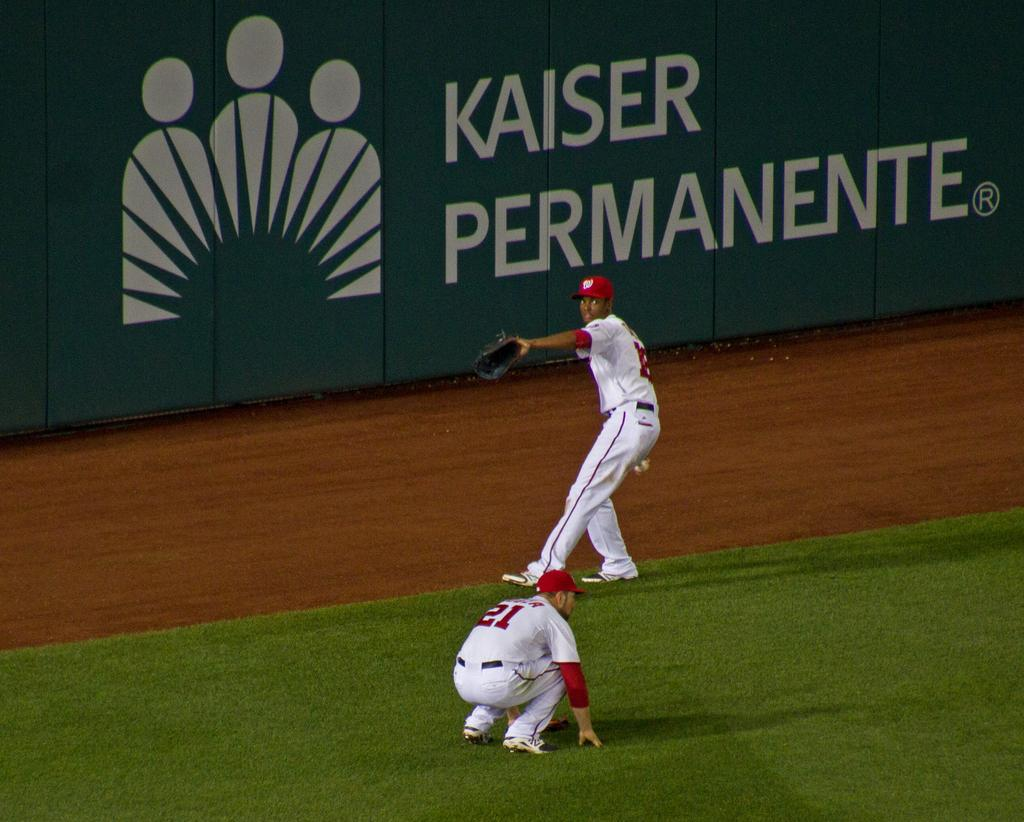<image>
Write a terse but informative summary of the picture. Two members of a baseball team out in the field with a Kaiser Permanente advertisment directly behind them on the wall. 